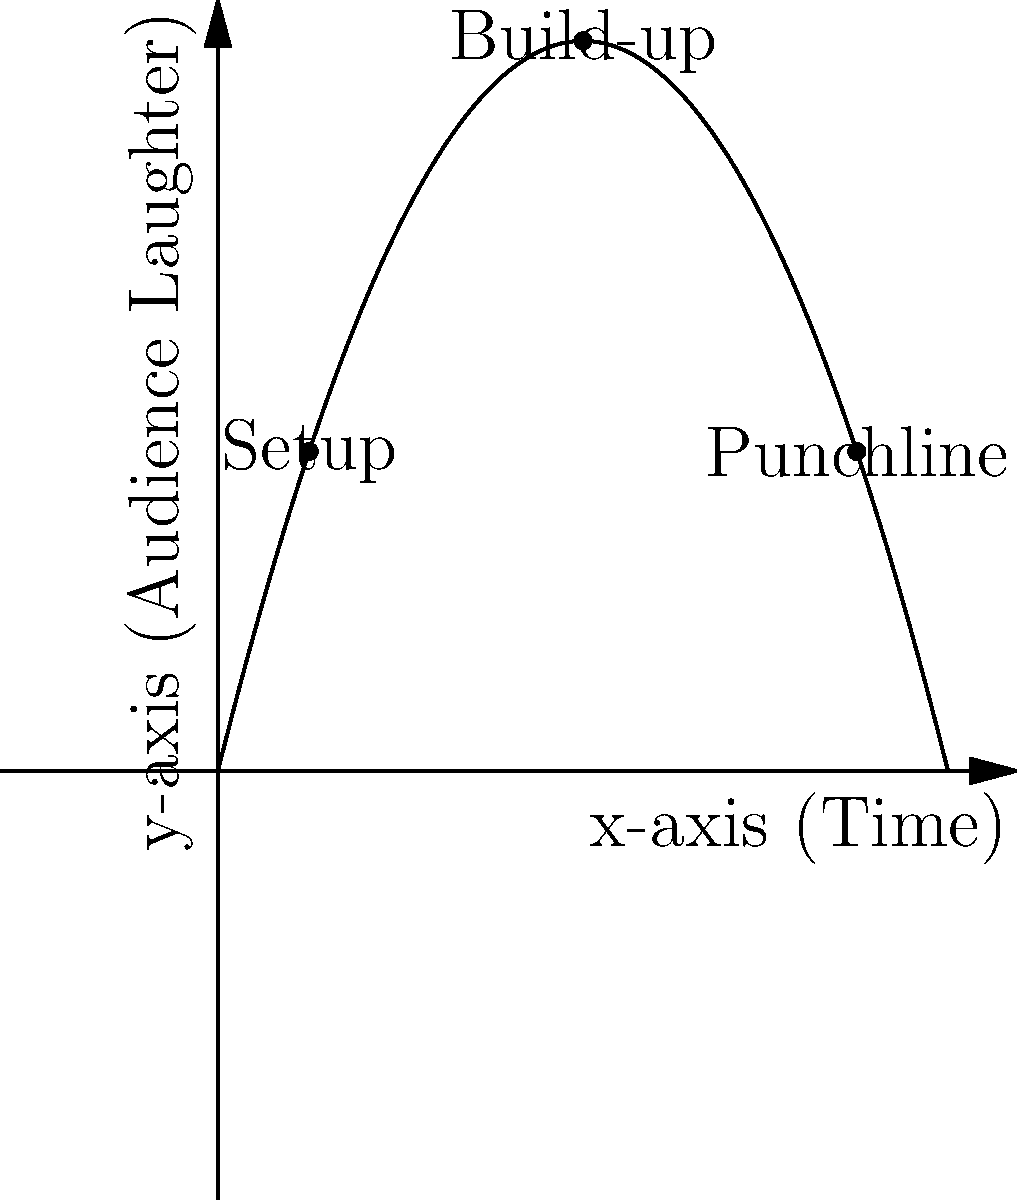In the coordinate plane above, the trajectory of a joke's punchline is plotted, where the x-axis represents time and the y-axis represents audience laughter. The curve is represented by the function $f(x) = -0.5x^2 + 4x$. If the punchline is delivered at $x=7$, what is the maximum laughter level achieved, and at what point in time does it occur? To find the maximum laughter level and when it occurs, we need to follow these steps:

1) The function given is $f(x) = -0.5x^2 + 4x$

2) To find the maximum point, we need to find where the derivative of the function equals zero:
   $f'(x) = -x + 4$
   Set $f'(x) = 0$:
   $-x + 4 = 0$
   $x = 4$

3) This means the maximum occurs at $x = 4$

4) To find the maximum laughter level, we plug $x = 4$ into the original function:
   $f(4) = -0.5(4)^2 + 4(4)$
   $f(4) = -0.5(16) + 16$
   $f(4) = -8 + 16 = 8$

5) Therefore, the maximum laughter level is 8, occurring at $x = 4$

6) Note that this maximum occurs before the punchline is delivered at $x = 7$, which is typical in joke structure where tension builds to a peak before release.
Answer: Maximum laughter level: 8; Time: $x = 4$ 